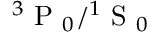<formula> <loc_0><loc_0><loc_500><loc_500>{ { ^ { 3 } P _ { 0 } } } / { { ^ { 1 } S _ { 0 } } }</formula> 